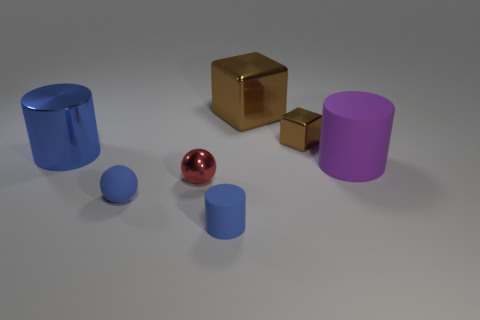Subtract all tiny blue matte cylinders. How many cylinders are left? 2 Subtract all cubes. How many objects are left? 5 Add 7 large gray rubber blocks. How many large gray rubber blocks exist? 7 Add 1 blue shiny cylinders. How many objects exist? 8 Subtract all blue spheres. How many spheres are left? 1 Subtract 0 cyan blocks. How many objects are left? 7 Subtract 2 cylinders. How many cylinders are left? 1 Subtract all brown cylinders. Subtract all blue blocks. How many cylinders are left? 3 Subtract all yellow cylinders. How many yellow spheres are left? 0 Subtract all large purple rubber cubes. Subtract all small cubes. How many objects are left? 6 